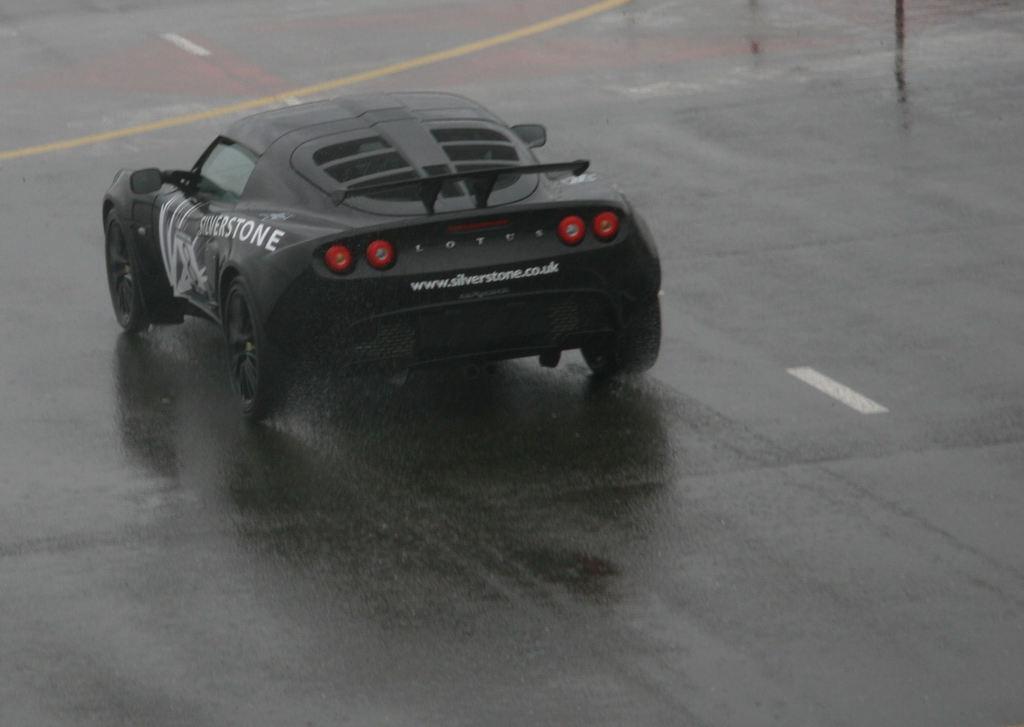Could you give a brief overview of what you see in this image? In this image we can see a black color car on the road. 